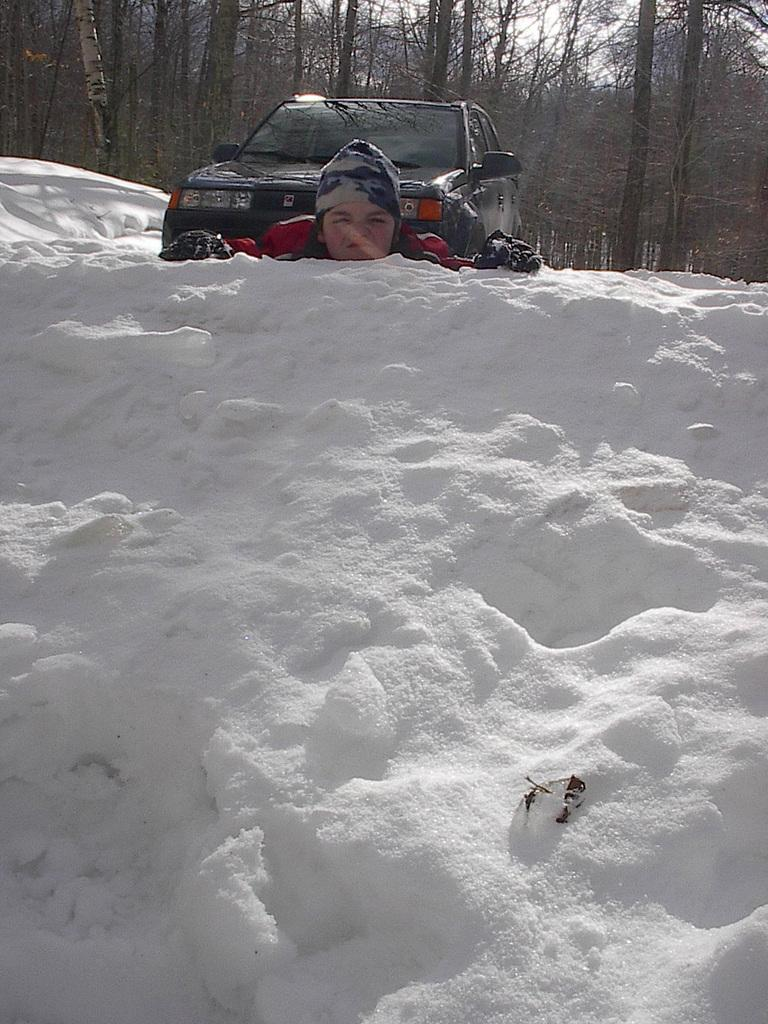What is located on the right side of the image? There is an object on a snowy surface on the right side of the image. What can be seen in the background of the image? There are trees, a vehicle, a person, and the sky visible in the background of the image. What type of ink can be seen spilled on the seashore in the image? There is no ink or seashore present in the image; it features an object on a snowy surface and a background with trees, a vehicle, a person, and the sky. 